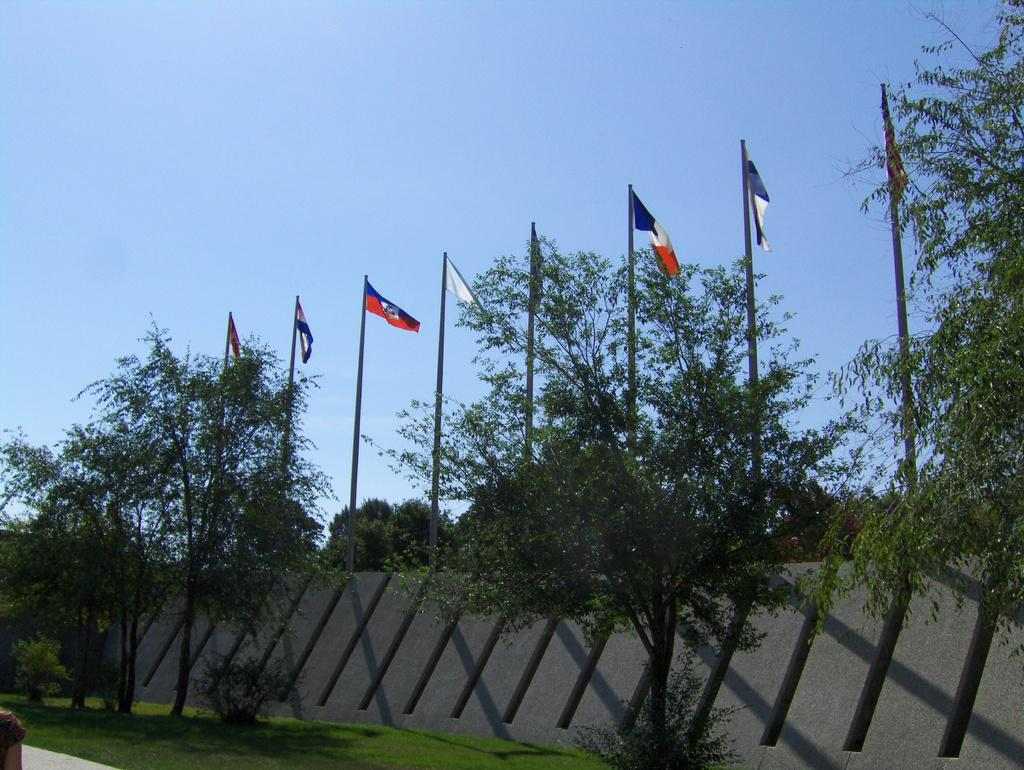What is present in the image that serves as a barrier or divider? There is a wall in the image. What type of decorative or symbolic objects can be seen in the image? There are flags in the image. Where are the flags located in relation to the trees? The flags are between trees. What can be seen in the distance behind the trees and flags? There is a sky visible in the background of the image. Where is the church located in the image? There is no church present in the image. Are any masks visible on the flags in the image? There are no masks present on the flags in the image. 